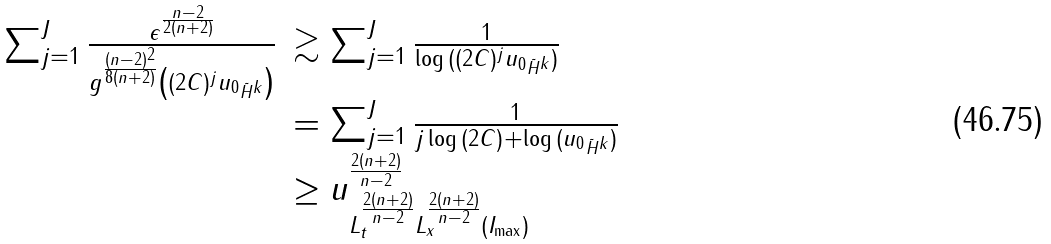<formula> <loc_0><loc_0><loc_500><loc_500>\begin{array} { l l } \sum _ { j = 1 } ^ { J } \frac { \epsilon ^ { \frac { n - 2 } { 2 ( n + 2 ) } } } { g ^ { \frac { ( n - 2 ) ^ { 2 } } { 8 ( n + 2 ) } } \left ( ( 2 C ) ^ { j } \| u _ { 0 } \| _ { \tilde { H } ^ { k } } \right ) } & \gtrsim \sum _ { j = 1 } ^ { J } \frac { 1 } { \log { ( ( 2 C ) ^ { j } \| u _ { 0 } \| _ { \tilde { H } ^ { k } } ) } } \\ & = \sum _ { j = 1 } ^ { J } \frac { 1 } { j \log { ( 2 C ) } + \log { ( \| u _ { 0 } \| _ { \tilde { H } ^ { k } } ) } } \\ & \geq \| u \| ^ { \frac { 2 ( n + 2 ) } { n - 2 } } _ { L _ { t } ^ { \frac { 2 ( n + 2 ) } { n - 2 } } L _ { x } ^ { \frac { 2 ( n + 2 ) } { n - 2 } } ( I _ { \max } ) } \end{array}</formula> 